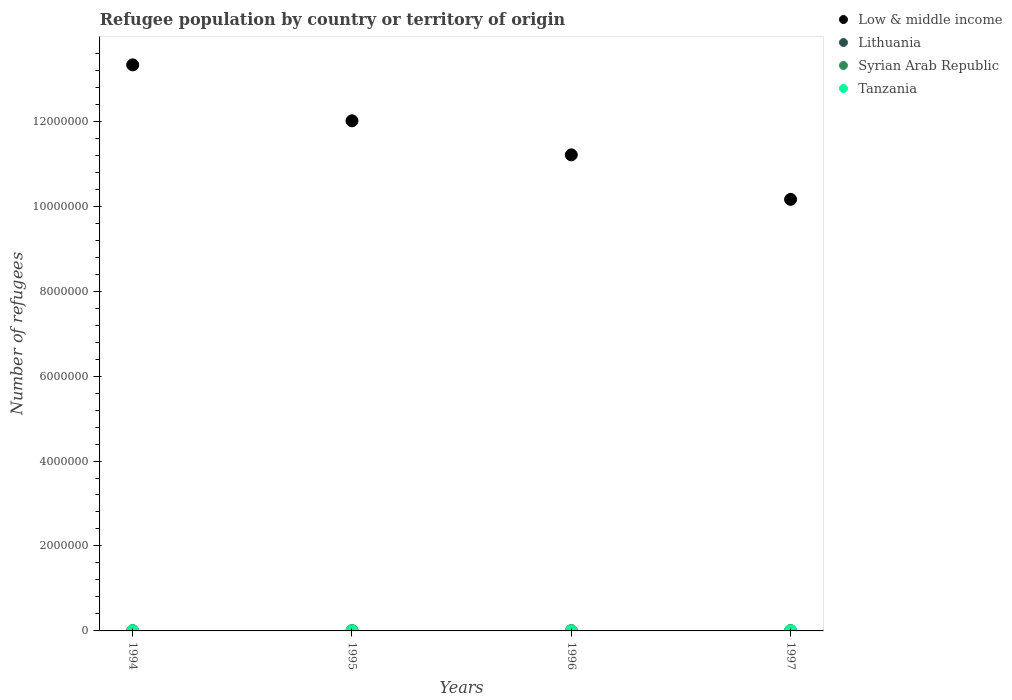What is the number of refugees in Tanzania in 1994?
Give a very brief answer. 62. Across all years, what is the maximum number of refugees in Syrian Arab Republic?
Make the answer very short. 8653. Across all years, what is the minimum number of refugees in Syrian Arab Republic?
Your answer should be compact. 7087. What is the total number of refugees in Tanzania in the graph?
Ensure brevity in your answer.  261. What is the difference between the number of refugees in Low & middle income in 1994 and that in 1995?
Make the answer very short. 1.32e+06. What is the difference between the number of refugees in Low & middle income in 1994 and the number of refugees in Lithuania in 1997?
Provide a succinct answer. 1.33e+07. What is the average number of refugees in Syrian Arab Republic per year?
Your answer should be compact. 8085.75. In the year 1996, what is the difference between the number of refugees in Low & middle income and number of refugees in Syrian Arab Republic?
Offer a terse response. 1.12e+07. In how many years, is the number of refugees in Lithuania greater than 4400000?
Your answer should be very brief. 0. What is the ratio of the number of refugees in Tanzania in 1996 to that in 1997?
Your response must be concise. 0.98. Is the difference between the number of refugees in Low & middle income in 1996 and 1997 greater than the difference between the number of refugees in Syrian Arab Republic in 1996 and 1997?
Keep it short and to the point. Yes. What is the difference between the highest and the second highest number of refugees in Low & middle income?
Provide a succinct answer. 1.32e+06. What is the difference between the highest and the lowest number of refugees in Tanzania?
Provide a succinct answer. 6. Is it the case that in every year, the sum of the number of refugees in Tanzania and number of refugees in Syrian Arab Republic  is greater than the sum of number of refugees in Low & middle income and number of refugees in Lithuania?
Your answer should be compact. No. Is the number of refugees in Syrian Arab Republic strictly greater than the number of refugees in Lithuania over the years?
Offer a terse response. Yes. Is the number of refugees in Lithuania strictly less than the number of refugees in Low & middle income over the years?
Give a very brief answer. Yes. How many years are there in the graph?
Provide a short and direct response. 4. What is the difference between two consecutive major ticks on the Y-axis?
Offer a very short reply. 2.00e+06. Are the values on the major ticks of Y-axis written in scientific E-notation?
Your response must be concise. No. Does the graph contain any zero values?
Your response must be concise. No. How many legend labels are there?
Your answer should be compact. 4. How are the legend labels stacked?
Your response must be concise. Vertical. What is the title of the graph?
Your answer should be compact. Refugee population by country or territory of origin. What is the label or title of the X-axis?
Ensure brevity in your answer.  Years. What is the label or title of the Y-axis?
Offer a very short reply. Number of refugees. What is the Number of refugees of Low & middle income in 1994?
Provide a succinct answer. 1.33e+07. What is the Number of refugees of Syrian Arab Republic in 1994?
Ensure brevity in your answer.  7087. What is the Number of refugees of Low & middle income in 1995?
Provide a short and direct response. 1.20e+07. What is the Number of refugees of Lithuania in 1995?
Offer a terse response. 109. What is the Number of refugees in Syrian Arab Republic in 1995?
Give a very brief answer. 7994. What is the Number of refugees in Tanzania in 1995?
Your answer should be very brief. 68. What is the Number of refugees of Low & middle income in 1996?
Your answer should be very brief. 1.12e+07. What is the Number of refugees of Lithuania in 1996?
Provide a succinct answer. 662. What is the Number of refugees of Syrian Arab Republic in 1996?
Provide a succinct answer. 8609. What is the Number of refugees in Tanzania in 1996?
Provide a succinct answer. 65. What is the Number of refugees of Low & middle income in 1997?
Give a very brief answer. 1.02e+07. What is the Number of refugees in Lithuania in 1997?
Provide a succinct answer. 649. What is the Number of refugees in Syrian Arab Republic in 1997?
Your answer should be very brief. 8653. What is the Number of refugees of Tanzania in 1997?
Give a very brief answer. 66. Across all years, what is the maximum Number of refugees of Low & middle income?
Offer a terse response. 1.33e+07. Across all years, what is the maximum Number of refugees of Lithuania?
Keep it short and to the point. 662. Across all years, what is the maximum Number of refugees in Syrian Arab Republic?
Your answer should be very brief. 8653. Across all years, what is the maximum Number of refugees of Tanzania?
Make the answer very short. 68. Across all years, what is the minimum Number of refugees in Low & middle income?
Make the answer very short. 1.02e+07. Across all years, what is the minimum Number of refugees in Syrian Arab Republic?
Your response must be concise. 7087. Across all years, what is the minimum Number of refugees in Tanzania?
Your answer should be very brief. 62. What is the total Number of refugees of Low & middle income in the graph?
Offer a very short reply. 4.67e+07. What is the total Number of refugees in Lithuania in the graph?
Your response must be concise. 1483. What is the total Number of refugees in Syrian Arab Republic in the graph?
Make the answer very short. 3.23e+04. What is the total Number of refugees in Tanzania in the graph?
Your answer should be compact. 261. What is the difference between the Number of refugees of Low & middle income in 1994 and that in 1995?
Provide a short and direct response. 1.32e+06. What is the difference between the Number of refugees in Lithuania in 1994 and that in 1995?
Provide a succinct answer. -46. What is the difference between the Number of refugees of Syrian Arab Republic in 1994 and that in 1995?
Offer a very short reply. -907. What is the difference between the Number of refugees of Tanzania in 1994 and that in 1995?
Your answer should be compact. -6. What is the difference between the Number of refugees in Low & middle income in 1994 and that in 1996?
Provide a succinct answer. 2.12e+06. What is the difference between the Number of refugees of Lithuania in 1994 and that in 1996?
Keep it short and to the point. -599. What is the difference between the Number of refugees in Syrian Arab Republic in 1994 and that in 1996?
Your answer should be compact. -1522. What is the difference between the Number of refugees of Tanzania in 1994 and that in 1996?
Your answer should be compact. -3. What is the difference between the Number of refugees of Low & middle income in 1994 and that in 1997?
Keep it short and to the point. 3.17e+06. What is the difference between the Number of refugees of Lithuania in 1994 and that in 1997?
Offer a terse response. -586. What is the difference between the Number of refugees in Syrian Arab Republic in 1994 and that in 1997?
Provide a short and direct response. -1566. What is the difference between the Number of refugees in Tanzania in 1994 and that in 1997?
Offer a terse response. -4. What is the difference between the Number of refugees in Low & middle income in 1995 and that in 1996?
Your answer should be compact. 8.01e+05. What is the difference between the Number of refugees in Lithuania in 1995 and that in 1996?
Keep it short and to the point. -553. What is the difference between the Number of refugees of Syrian Arab Republic in 1995 and that in 1996?
Make the answer very short. -615. What is the difference between the Number of refugees of Low & middle income in 1995 and that in 1997?
Offer a terse response. 1.85e+06. What is the difference between the Number of refugees in Lithuania in 1995 and that in 1997?
Provide a succinct answer. -540. What is the difference between the Number of refugees of Syrian Arab Republic in 1995 and that in 1997?
Your answer should be compact. -659. What is the difference between the Number of refugees in Low & middle income in 1996 and that in 1997?
Make the answer very short. 1.05e+06. What is the difference between the Number of refugees in Syrian Arab Republic in 1996 and that in 1997?
Your answer should be very brief. -44. What is the difference between the Number of refugees of Low & middle income in 1994 and the Number of refugees of Lithuania in 1995?
Ensure brevity in your answer.  1.33e+07. What is the difference between the Number of refugees of Low & middle income in 1994 and the Number of refugees of Syrian Arab Republic in 1995?
Keep it short and to the point. 1.33e+07. What is the difference between the Number of refugees in Low & middle income in 1994 and the Number of refugees in Tanzania in 1995?
Provide a succinct answer. 1.33e+07. What is the difference between the Number of refugees in Lithuania in 1994 and the Number of refugees in Syrian Arab Republic in 1995?
Give a very brief answer. -7931. What is the difference between the Number of refugees of Lithuania in 1994 and the Number of refugees of Tanzania in 1995?
Keep it short and to the point. -5. What is the difference between the Number of refugees in Syrian Arab Republic in 1994 and the Number of refugees in Tanzania in 1995?
Ensure brevity in your answer.  7019. What is the difference between the Number of refugees in Low & middle income in 1994 and the Number of refugees in Lithuania in 1996?
Your answer should be compact. 1.33e+07. What is the difference between the Number of refugees in Low & middle income in 1994 and the Number of refugees in Syrian Arab Republic in 1996?
Ensure brevity in your answer.  1.33e+07. What is the difference between the Number of refugees of Low & middle income in 1994 and the Number of refugees of Tanzania in 1996?
Provide a succinct answer. 1.33e+07. What is the difference between the Number of refugees of Lithuania in 1994 and the Number of refugees of Syrian Arab Republic in 1996?
Provide a short and direct response. -8546. What is the difference between the Number of refugees of Lithuania in 1994 and the Number of refugees of Tanzania in 1996?
Make the answer very short. -2. What is the difference between the Number of refugees of Syrian Arab Republic in 1994 and the Number of refugees of Tanzania in 1996?
Ensure brevity in your answer.  7022. What is the difference between the Number of refugees of Low & middle income in 1994 and the Number of refugees of Lithuania in 1997?
Offer a terse response. 1.33e+07. What is the difference between the Number of refugees in Low & middle income in 1994 and the Number of refugees in Syrian Arab Republic in 1997?
Provide a succinct answer. 1.33e+07. What is the difference between the Number of refugees of Low & middle income in 1994 and the Number of refugees of Tanzania in 1997?
Offer a very short reply. 1.33e+07. What is the difference between the Number of refugees of Lithuania in 1994 and the Number of refugees of Syrian Arab Republic in 1997?
Your answer should be very brief. -8590. What is the difference between the Number of refugees of Lithuania in 1994 and the Number of refugees of Tanzania in 1997?
Provide a short and direct response. -3. What is the difference between the Number of refugees of Syrian Arab Republic in 1994 and the Number of refugees of Tanzania in 1997?
Your response must be concise. 7021. What is the difference between the Number of refugees in Low & middle income in 1995 and the Number of refugees in Lithuania in 1996?
Give a very brief answer. 1.20e+07. What is the difference between the Number of refugees of Low & middle income in 1995 and the Number of refugees of Syrian Arab Republic in 1996?
Give a very brief answer. 1.20e+07. What is the difference between the Number of refugees in Low & middle income in 1995 and the Number of refugees in Tanzania in 1996?
Provide a succinct answer. 1.20e+07. What is the difference between the Number of refugees of Lithuania in 1995 and the Number of refugees of Syrian Arab Republic in 1996?
Give a very brief answer. -8500. What is the difference between the Number of refugees of Syrian Arab Republic in 1995 and the Number of refugees of Tanzania in 1996?
Offer a very short reply. 7929. What is the difference between the Number of refugees in Low & middle income in 1995 and the Number of refugees in Lithuania in 1997?
Your answer should be very brief. 1.20e+07. What is the difference between the Number of refugees of Low & middle income in 1995 and the Number of refugees of Syrian Arab Republic in 1997?
Offer a very short reply. 1.20e+07. What is the difference between the Number of refugees in Low & middle income in 1995 and the Number of refugees in Tanzania in 1997?
Give a very brief answer. 1.20e+07. What is the difference between the Number of refugees in Lithuania in 1995 and the Number of refugees in Syrian Arab Republic in 1997?
Your answer should be compact. -8544. What is the difference between the Number of refugees of Syrian Arab Republic in 1995 and the Number of refugees of Tanzania in 1997?
Offer a very short reply. 7928. What is the difference between the Number of refugees of Low & middle income in 1996 and the Number of refugees of Lithuania in 1997?
Give a very brief answer. 1.12e+07. What is the difference between the Number of refugees in Low & middle income in 1996 and the Number of refugees in Syrian Arab Republic in 1997?
Offer a very short reply. 1.12e+07. What is the difference between the Number of refugees of Low & middle income in 1996 and the Number of refugees of Tanzania in 1997?
Give a very brief answer. 1.12e+07. What is the difference between the Number of refugees in Lithuania in 1996 and the Number of refugees in Syrian Arab Republic in 1997?
Make the answer very short. -7991. What is the difference between the Number of refugees in Lithuania in 1996 and the Number of refugees in Tanzania in 1997?
Ensure brevity in your answer.  596. What is the difference between the Number of refugees in Syrian Arab Republic in 1996 and the Number of refugees in Tanzania in 1997?
Your answer should be compact. 8543. What is the average Number of refugees in Low & middle income per year?
Provide a short and direct response. 1.17e+07. What is the average Number of refugees of Lithuania per year?
Give a very brief answer. 370.75. What is the average Number of refugees of Syrian Arab Republic per year?
Offer a terse response. 8085.75. What is the average Number of refugees of Tanzania per year?
Your answer should be compact. 65.25. In the year 1994, what is the difference between the Number of refugees of Low & middle income and Number of refugees of Lithuania?
Provide a succinct answer. 1.33e+07. In the year 1994, what is the difference between the Number of refugees in Low & middle income and Number of refugees in Syrian Arab Republic?
Ensure brevity in your answer.  1.33e+07. In the year 1994, what is the difference between the Number of refugees of Low & middle income and Number of refugees of Tanzania?
Your answer should be compact. 1.33e+07. In the year 1994, what is the difference between the Number of refugees in Lithuania and Number of refugees in Syrian Arab Republic?
Keep it short and to the point. -7024. In the year 1994, what is the difference between the Number of refugees in Lithuania and Number of refugees in Tanzania?
Your answer should be very brief. 1. In the year 1994, what is the difference between the Number of refugees in Syrian Arab Republic and Number of refugees in Tanzania?
Provide a succinct answer. 7025. In the year 1995, what is the difference between the Number of refugees of Low & middle income and Number of refugees of Lithuania?
Provide a short and direct response. 1.20e+07. In the year 1995, what is the difference between the Number of refugees in Low & middle income and Number of refugees in Syrian Arab Republic?
Give a very brief answer. 1.20e+07. In the year 1995, what is the difference between the Number of refugees in Low & middle income and Number of refugees in Tanzania?
Your response must be concise. 1.20e+07. In the year 1995, what is the difference between the Number of refugees in Lithuania and Number of refugees in Syrian Arab Republic?
Provide a succinct answer. -7885. In the year 1995, what is the difference between the Number of refugees in Lithuania and Number of refugees in Tanzania?
Your response must be concise. 41. In the year 1995, what is the difference between the Number of refugees in Syrian Arab Republic and Number of refugees in Tanzania?
Provide a short and direct response. 7926. In the year 1996, what is the difference between the Number of refugees in Low & middle income and Number of refugees in Lithuania?
Provide a short and direct response. 1.12e+07. In the year 1996, what is the difference between the Number of refugees in Low & middle income and Number of refugees in Syrian Arab Republic?
Offer a terse response. 1.12e+07. In the year 1996, what is the difference between the Number of refugees of Low & middle income and Number of refugees of Tanzania?
Your response must be concise. 1.12e+07. In the year 1996, what is the difference between the Number of refugees of Lithuania and Number of refugees of Syrian Arab Republic?
Offer a very short reply. -7947. In the year 1996, what is the difference between the Number of refugees in Lithuania and Number of refugees in Tanzania?
Provide a short and direct response. 597. In the year 1996, what is the difference between the Number of refugees in Syrian Arab Republic and Number of refugees in Tanzania?
Make the answer very short. 8544. In the year 1997, what is the difference between the Number of refugees of Low & middle income and Number of refugees of Lithuania?
Make the answer very short. 1.02e+07. In the year 1997, what is the difference between the Number of refugees of Low & middle income and Number of refugees of Syrian Arab Republic?
Provide a short and direct response. 1.02e+07. In the year 1997, what is the difference between the Number of refugees in Low & middle income and Number of refugees in Tanzania?
Provide a short and direct response. 1.02e+07. In the year 1997, what is the difference between the Number of refugees of Lithuania and Number of refugees of Syrian Arab Republic?
Provide a short and direct response. -8004. In the year 1997, what is the difference between the Number of refugees of Lithuania and Number of refugees of Tanzania?
Keep it short and to the point. 583. In the year 1997, what is the difference between the Number of refugees of Syrian Arab Republic and Number of refugees of Tanzania?
Make the answer very short. 8587. What is the ratio of the Number of refugees of Low & middle income in 1994 to that in 1995?
Your response must be concise. 1.11. What is the ratio of the Number of refugees of Lithuania in 1994 to that in 1995?
Your answer should be compact. 0.58. What is the ratio of the Number of refugees of Syrian Arab Republic in 1994 to that in 1995?
Give a very brief answer. 0.89. What is the ratio of the Number of refugees in Tanzania in 1994 to that in 1995?
Provide a short and direct response. 0.91. What is the ratio of the Number of refugees in Low & middle income in 1994 to that in 1996?
Give a very brief answer. 1.19. What is the ratio of the Number of refugees in Lithuania in 1994 to that in 1996?
Keep it short and to the point. 0.1. What is the ratio of the Number of refugees in Syrian Arab Republic in 1994 to that in 1996?
Provide a short and direct response. 0.82. What is the ratio of the Number of refugees of Tanzania in 1994 to that in 1996?
Your response must be concise. 0.95. What is the ratio of the Number of refugees in Low & middle income in 1994 to that in 1997?
Give a very brief answer. 1.31. What is the ratio of the Number of refugees in Lithuania in 1994 to that in 1997?
Make the answer very short. 0.1. What is the ratio of the Number of refugees in Syrian Arab Republic in 1994 to that in 1997?
Make the answer very short. 0.82. What is the ratio of the Number of refugees in Tanzania in 1994 to that in 1997?
Offer a very short reply. 0.94. What is the ratio of the Number of refugees of Low & middle income in 1995 to that in 1996?
Your response must be concise. 1.07. What is the ratio of the Number of refugees of Lithuania in 1995 to that in 1996?
Provide a succinct answer. 0.16. What is the ratio of the Number of refugees in Tanzania in 1995 to that in 1996?
Keep it short and to the point. 1.05. What is the ratio of the Number of refugees in Low & middle income in 1995 to that in 1997?
Ensure brevity in your answer.  1.18. What is the ratio of the Number of refugees in Lithuania in 1995 to that in 1997?
Give a very brief answer. 0.17. What is the ratio of the Number of refugees in Syrian Arab Republic in 1995 to that in 1997?
Keep it short and to the point. 0.92. What is the ratio of the Number of refugees in Tanzania in 1995 to that in 1997?
Your response must be concise. 1.03. What is the ratio of the Number of refugees of Low & middle income in 1996 to that in 1997?
Your answer should be very brief. 1.1. What is the ratio of the Number of refugees in Syrian Arab Republic in 1996 to that in 1997?
Provide a short and direct response. 0.99. What is the difference between the highest and the second highest Number of refugees in Low & middle income?
Your answer should be very brief. 1.32e+06. What is the difference between the highest and the second highest Number of refugees in Tanzania?
Provide a short and direct response. 2. What is the difference between the highest and the lowest Number of refugees in Low & middle income?
Keep it short and to the point. 3.17e+06. What is the difference between the highest and the lowest Number of refugees of Lithuania?
Offer a terse response. 599. What is the difference between the highest and the lowest Number of refugees in Syrian Arab Republic?
Offer a very short reply. 1566. What is the difference between the highest and the lowest Number of refugees in Tanzania?
Your answer should be compact. 6. 